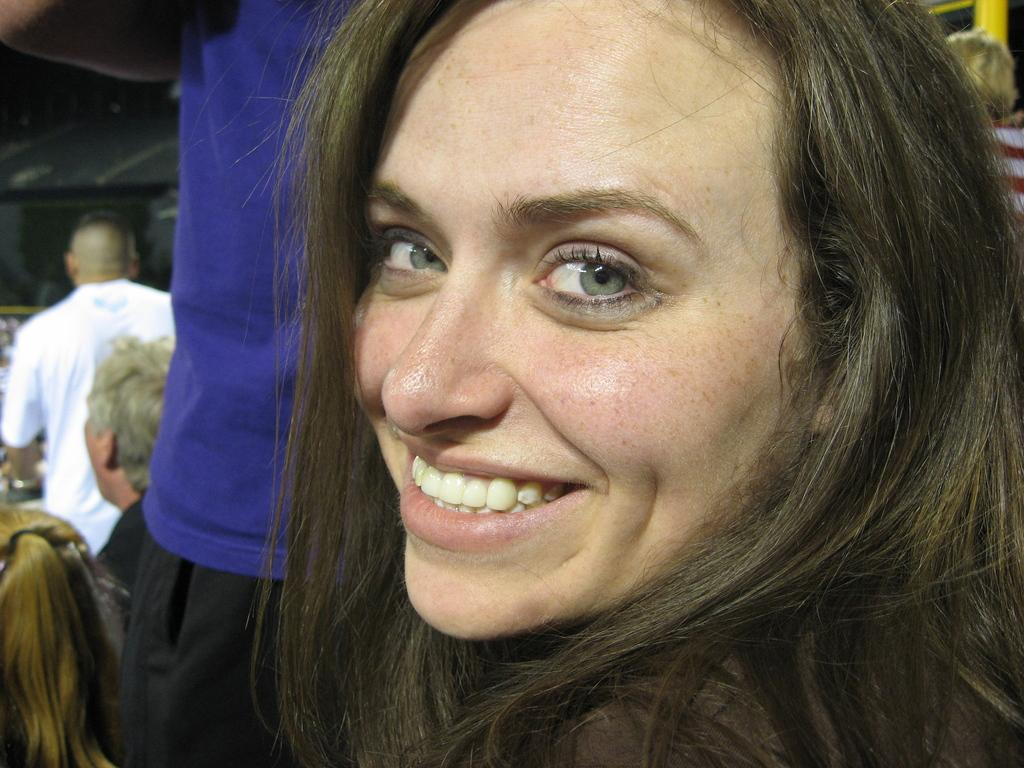Who is present in the image? There is a woman in the image. What is the woman doing in the image? The woman is smiling in the image. Can you describe the background of the image? There is a group of people in the background of the image. What type of duck can be seen in the image? There is no duck present in the image. What season is depicted in the image? The provided facts do not mention any seasonal details, so it cannot be determined from the image. 